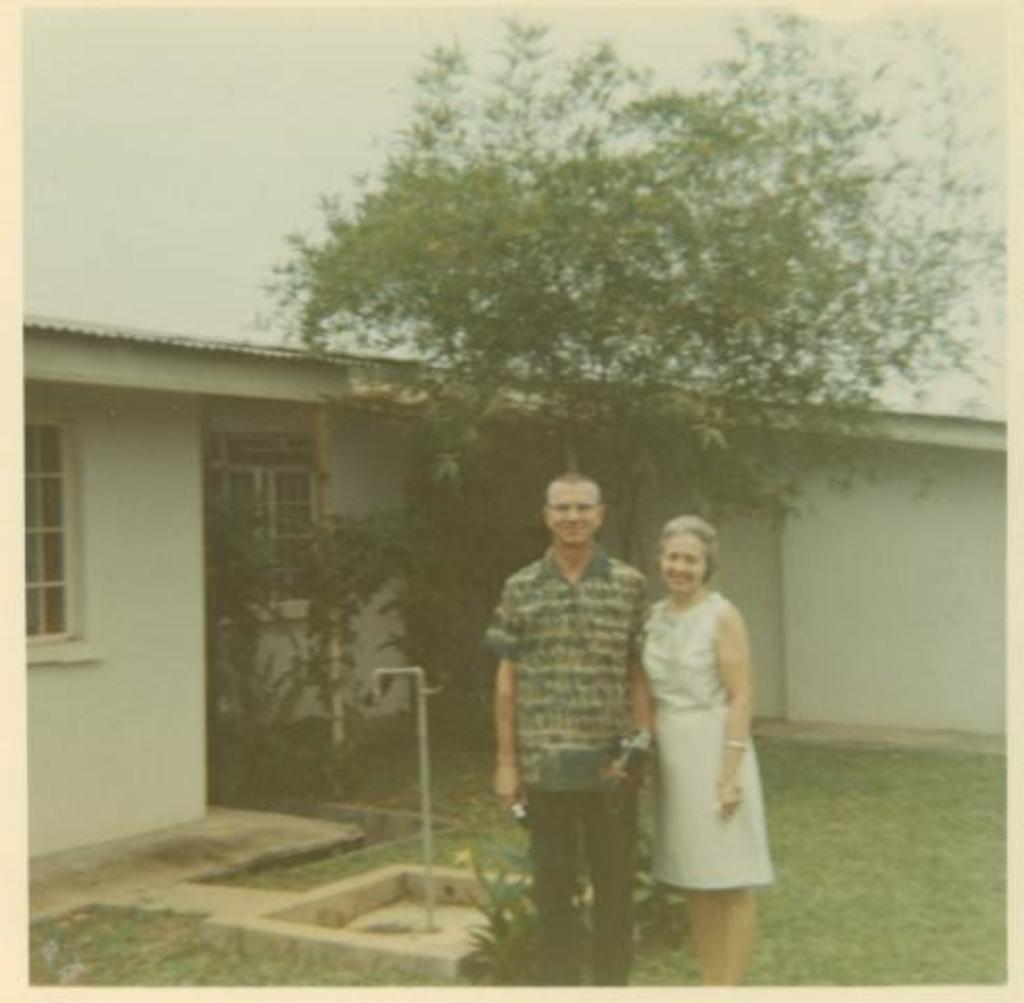What is the main object in the image? There is a photocopy in the image. Are there any people present in the image? Yes, there are people in the image. What type of structure can be seen in the image? There is a house in the image. What natural elements are present in the image? There are trees, plants, and grass in the image. What is visible on the ground in the image? There are objects on the ground in the image. What type of bells can be heard ringing in the image? There are no bells present in the image, and therefore no sound can be heard. 